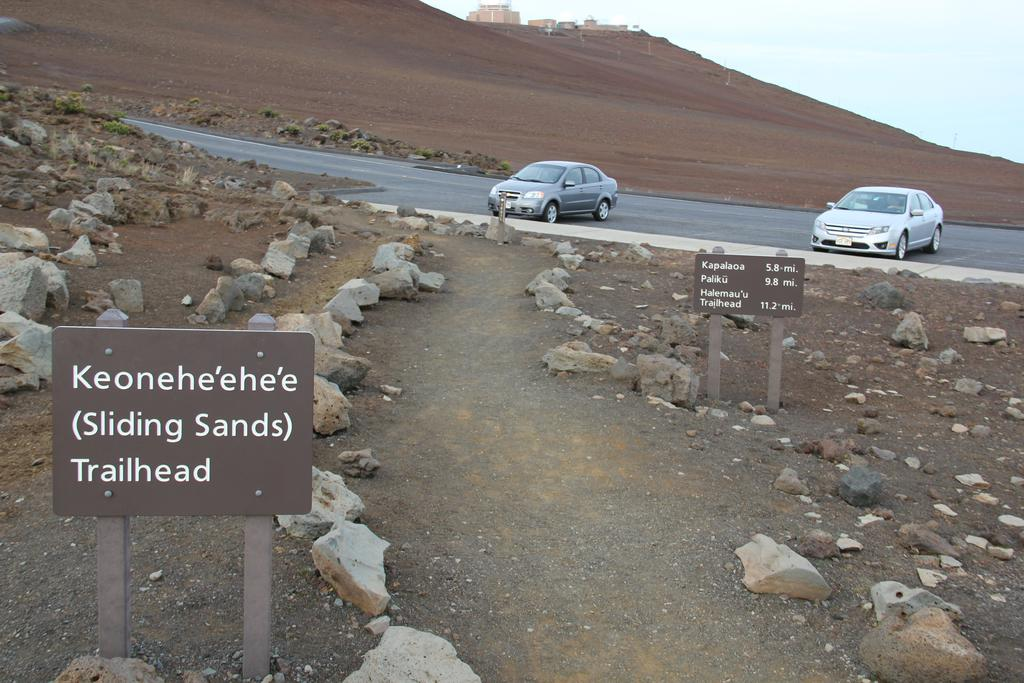What can be seen on the sign boards in the image? The information on the sign boards is not visible in the image, but we can see that there are sign boards present. What type of natural elements are in the image? There are rocks in the image. What type of vehicles are on the road in the image? There are cars on the road in the image. What type of structures can be seen in the background of the image? There are buildings in the background of the image. What is the tendency of the plastic to provide shade in the image? There is no plastic or indication of shade in the image. What type of plastic objects can be seen in the image? There are no plastic objects present in the image. 